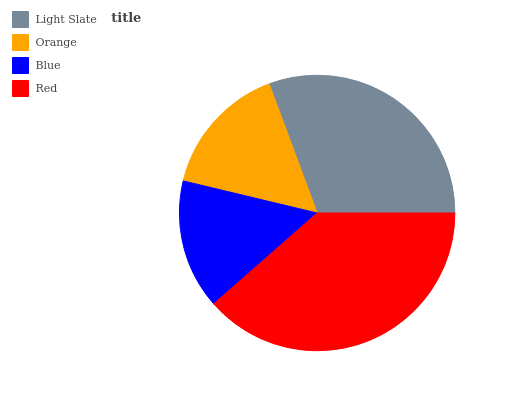Is Blue the minimum?
Answer yes or no. Yes. Is Red the maximum?
Answer yes or no. Yes. Is Orange the minimum?
Answer yes or no. No. Is Orange the maximum?
Answer yes or no. No. Is Light Slate greater than Orange?
Answer yes or no. Yes. Is Orange less than Light Slate?
Answer yes or no. Yes. Is Orange greater than Light Slate?
Answer yes or no. No. Is Light Slate less than Orange?
Answer yes or no. No. Is Light Slate the high median?
Answer yes or no. Yes. Is Orange the low median?
Answer yes or no. Yes. Is Blue the high median?
Answer yes or no. No. Is Light Slate the low median?
Answer yes or no. No. 